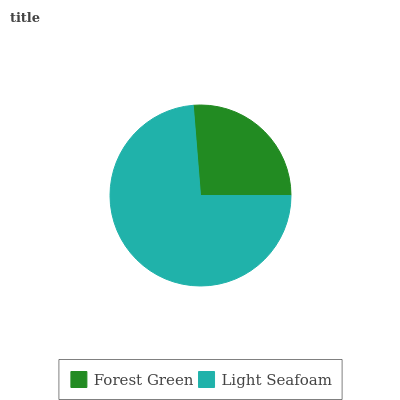Is Forest Green the minimum?
Answer yes or no. Yes. Is Light Seafoam the maximum?
Answer yes or no. Yes. Is Light Seafoam the minimum?
Answer yes or no. No. Is Light Seafoam greater than Forest Green?
Answer yes or no. Yes. Is Forest Green less than Light Seafoam?
Answer yes or no. Yes. Is Forest Green greater than Light Seafoam?
Answer yes or no. No. Is Light Seafoam less than Forest Green?
Answer yes or no. No. Is Light Seafoam the high median?
Answer yes or no. Yes. Is Forest Green the low median?
Answer yes or no. Yes. Is Forest Green the high median?
Answer yes or no. No. Is Light Seafoam the low median?
Answer yes or no. No. 